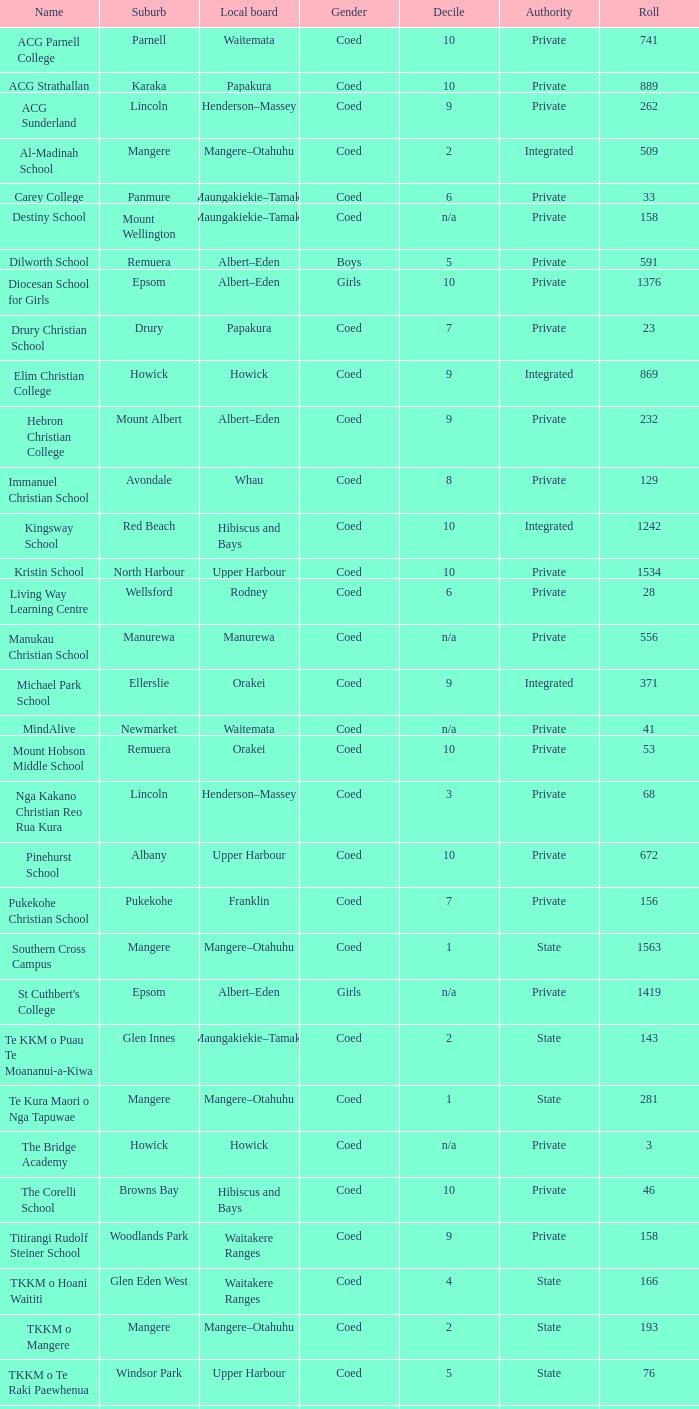Parse the full table. {'header': ['Name', 'Suburb', 'Local board', 'Gender', 'Decile', 'Authority', 'Roll'], 'rows': [['ACG Parnell College', 'Parnell', 'Waitemata', 'Coed', '10', 'Private', '741'], ['ACG Strathallan', 'Karaka', 'Papakura', 'Coed', '10', 'Private', '889'], ['ACG Sunderland', 'Lincoln', 'Henderson–Massey', 'Coed', '9', 'Private', '262'], ['Al-Madinah School', 'Mangere', 'Mangere–Otahuhu', 'Coed', '2', 'Integrated', '509'], ['Carey College', 'Panmure', 'Maungakiekie–Tamaki', 'Coed', '6', 'Private', '33'], ['Destiny School', 'Mount Wellington', 'Maungakiekie–Tamaki', 'Coed', 'n/a', 'Private', '158'], ['Dilworth School', 'Remuera', 'Albert–Eden', 'Boys', '5', 'Private', '591'], ['Diocesan School for Girls', 'Epsom', 'Albert–Eden', 'Girls', '10', 'Private', '1376'], ['Drury Christian School', 'Drury', 'Papakura', 'Coed', '7', 'Private', '23'], ['Elim Christian College', 'Howick', 'Howick', 'Coed', '9', 'Integrated', '869'], ['Hebron Christian College', 'Mount Albert', 'Albert–Eden', 'Coed', '9', 'Private', '232'], ['Immanuel Christian School', 'Avondale', 'Whau', 'Coed', '8', 'Private', '129'], ['Kingsway School', 'Red Beach', 'Hibiscus and Bays', 'Coed', '10', 'Integrated', '1242'], ['Kristin School', 'North Harbour', 'Upper Harbour', 'Coed', '10', 'Private', '1534'], ['Living Way Learning Centre', 'Wellsford', 'Rodney', 'Coed', '6', 'Private', '28'], ['Manukau Christian School', 'Manurewa', 'Manurewa', 'Coed', 'n/a', 'Private', '556'], ['Michael Park School', 'Ellerslie', 'Orakei', 'Coed', '9', 'Integrated', '371'], ['MindAlive', 'Newmarket', 'Waitemata', 'Coed', 'n/a', 'Private', '41'], ['Mount Hobson Middle School', 'Remuera', 'Orakei', 'Coed', '10', 'Private', '53'], ['Nga Kakano Christian Reo Rua Kura', 'Lincoln', 'Henderson–Massey', 'Coed', '3', 'Private', '68'], ['Pinehurst School', 'Albany', 'Upper Harbour', 'Coed', '10', 'Private', '672'], ['Pukekohe Christian School', 'Pukekohe', 'Franklin', 'Coed', '7', 'Private', '156'], ['Southern Cross Campus', 'Mangere', 'Mangere–Otahuhu', 'Coed', '1', 'State', '1563'], ["St Cuthbert's College", 'Epsom', 'Albert–Eden', 'Girls', 'n/a', 'Private', '1419'], ['Te KKM o Puau Te Moananui-a-Kiwa', 'Glen Innes', 'Maungakiekie–Tamaki', 'Coed', '2', 'State', '143'], ['Te Kura Maori o Nga Tapuwae', 'Mangere', 'Mangere–Otahuhu', 'Coed', '1', 'State', '281'], ['The Bridge Academy', 'Howick', 'Howick', 'Coed', 'n/a', 'Private', '3'], ['The Corelli School', 'Browns Bay', 'Hibiscus and Bays', 'Coed', '10', 'Private', '46'], ['Titirangi Rudolf Steiner School', 'Woodlands Park', 'Waitakere Ranges', 'Coed', '9', 'Private', '158'], ['TKKM o Hoani Waititi', 'Glen Eden West', 'Waitakere Ranges', 'Coed', '4', 'State', '166'], ['TKKM o Mangere', 'Mangere', 'Mangere–Otahuhu', 'Coed', '2', 'State', '193'], ['TKKM o Te Raki Paewhenua', 'Windsor Park', 'Upper Harbour', 'Coed', '5', 'State', '76'], ['Tyndale Park Christian School', 'Flat Bush', 'Howick', 'Coed', 'n/a', 'Private', '120']]} What is the name when the local board is albert–eden, and a Decile of 9? Hebron Christian College. 